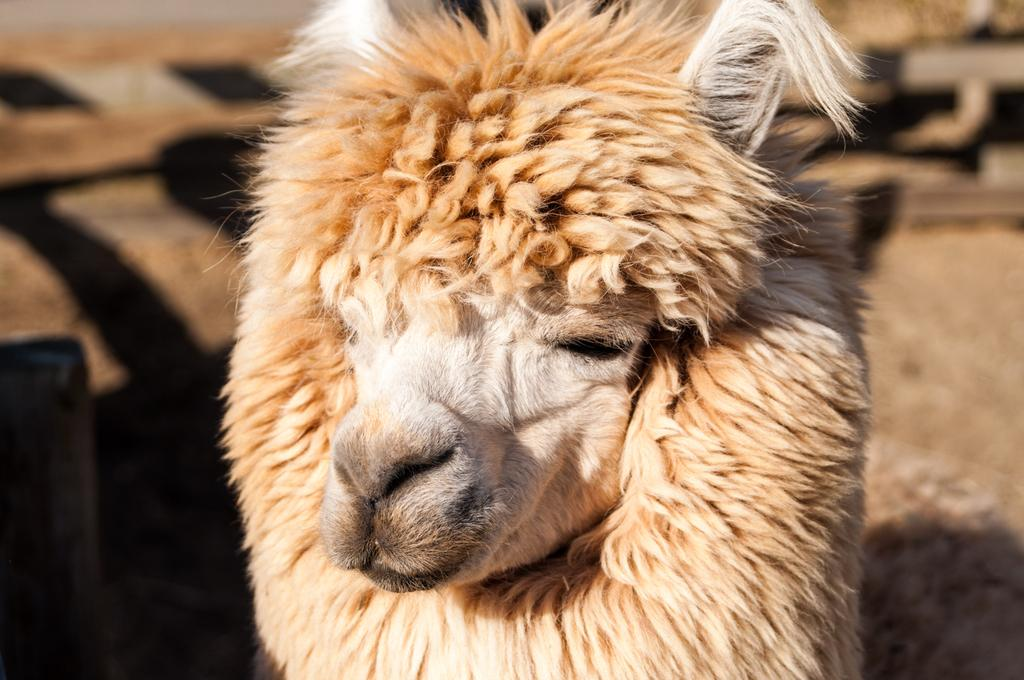What type of animal is in the image? There is a white color sheep in the image. Can you describe any other features in the image besides the sheep? There is a shadow in the image. What is the level of wealth depicted in the image? There is no indication of wealth in the image, as it only features a white color sheep and a shadow. What type of weather can be inferred from the image? There is no information about the weather in the image, as it only features a white color sheep and a shadow. 